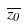Convert formula to latex. <formula><loc_0><loc_0><loc_500><loc_500>\overline { z _ { 0 } }</formula> 